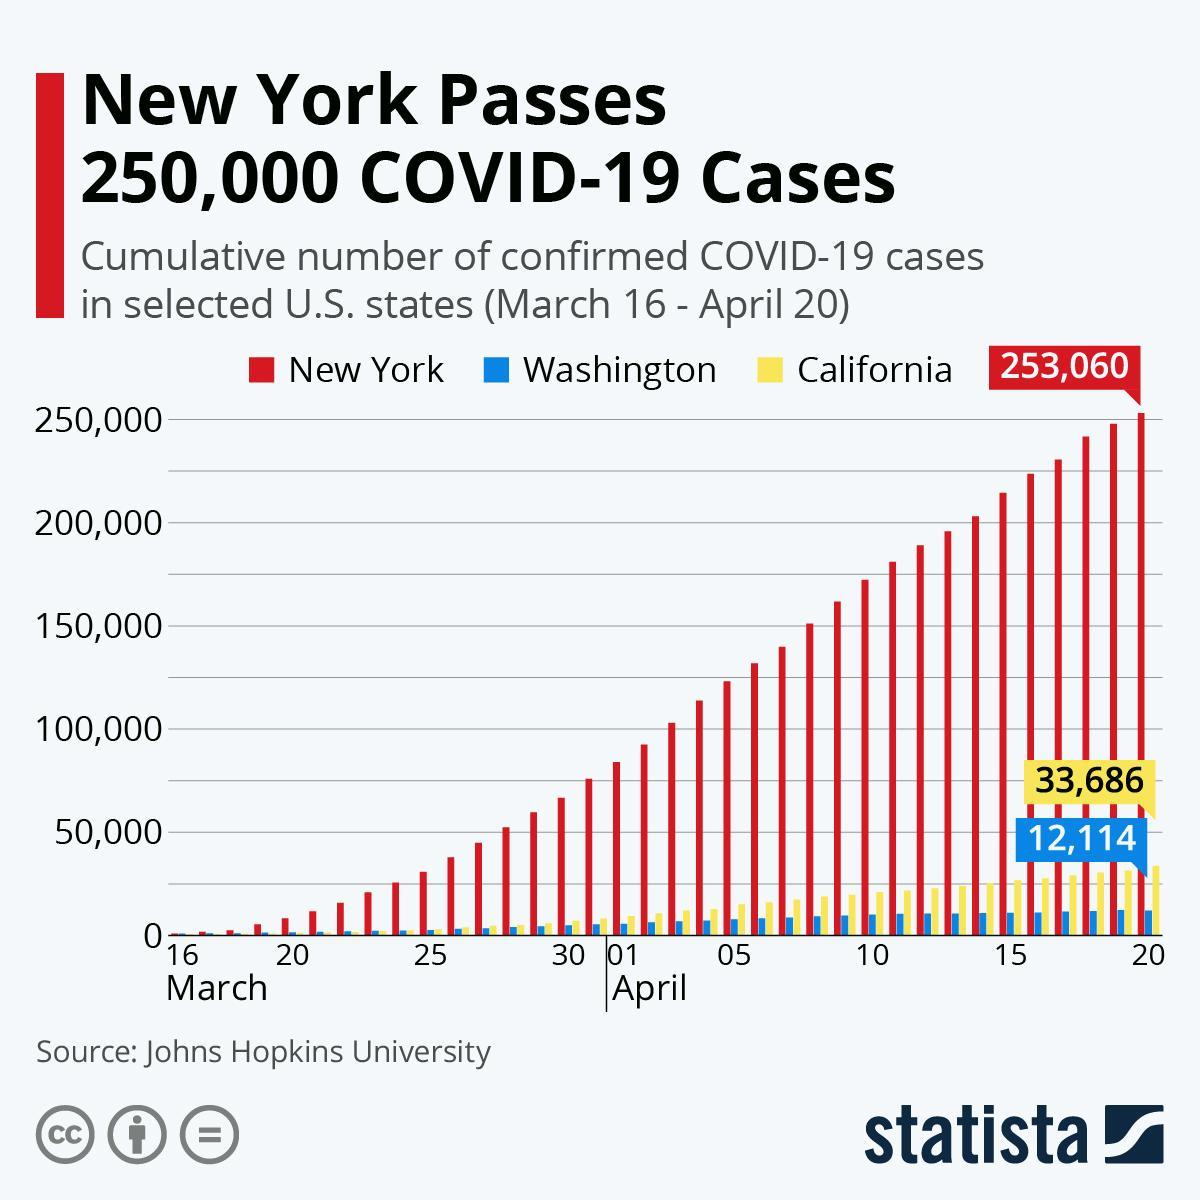What is the approximate no of Covid positive cases in New York during the end of March?
Answer the question with a short phrase. 75,000 What is the color code given to New York- green, yellow, blue, red? red What is the color code given to Washington- green, yellow, blue, red? blue What is the highest recorded no of Covid positive cases of California? 33,686 What is the color code given to California- green, yellow, blue, red? yellow What is the highest recorded no of Covid positive cases of Washington? 12,114 Covid data of how many different country's is shown in the infographic? 3 On which day of April, New York crossed the margin of 200,000 Covid positive cases? 14 On which day of April, California crossed the margin of 25,000 Covid positive cases? 14 Which country had exponential growth in Covid-19 cases after New York? California 